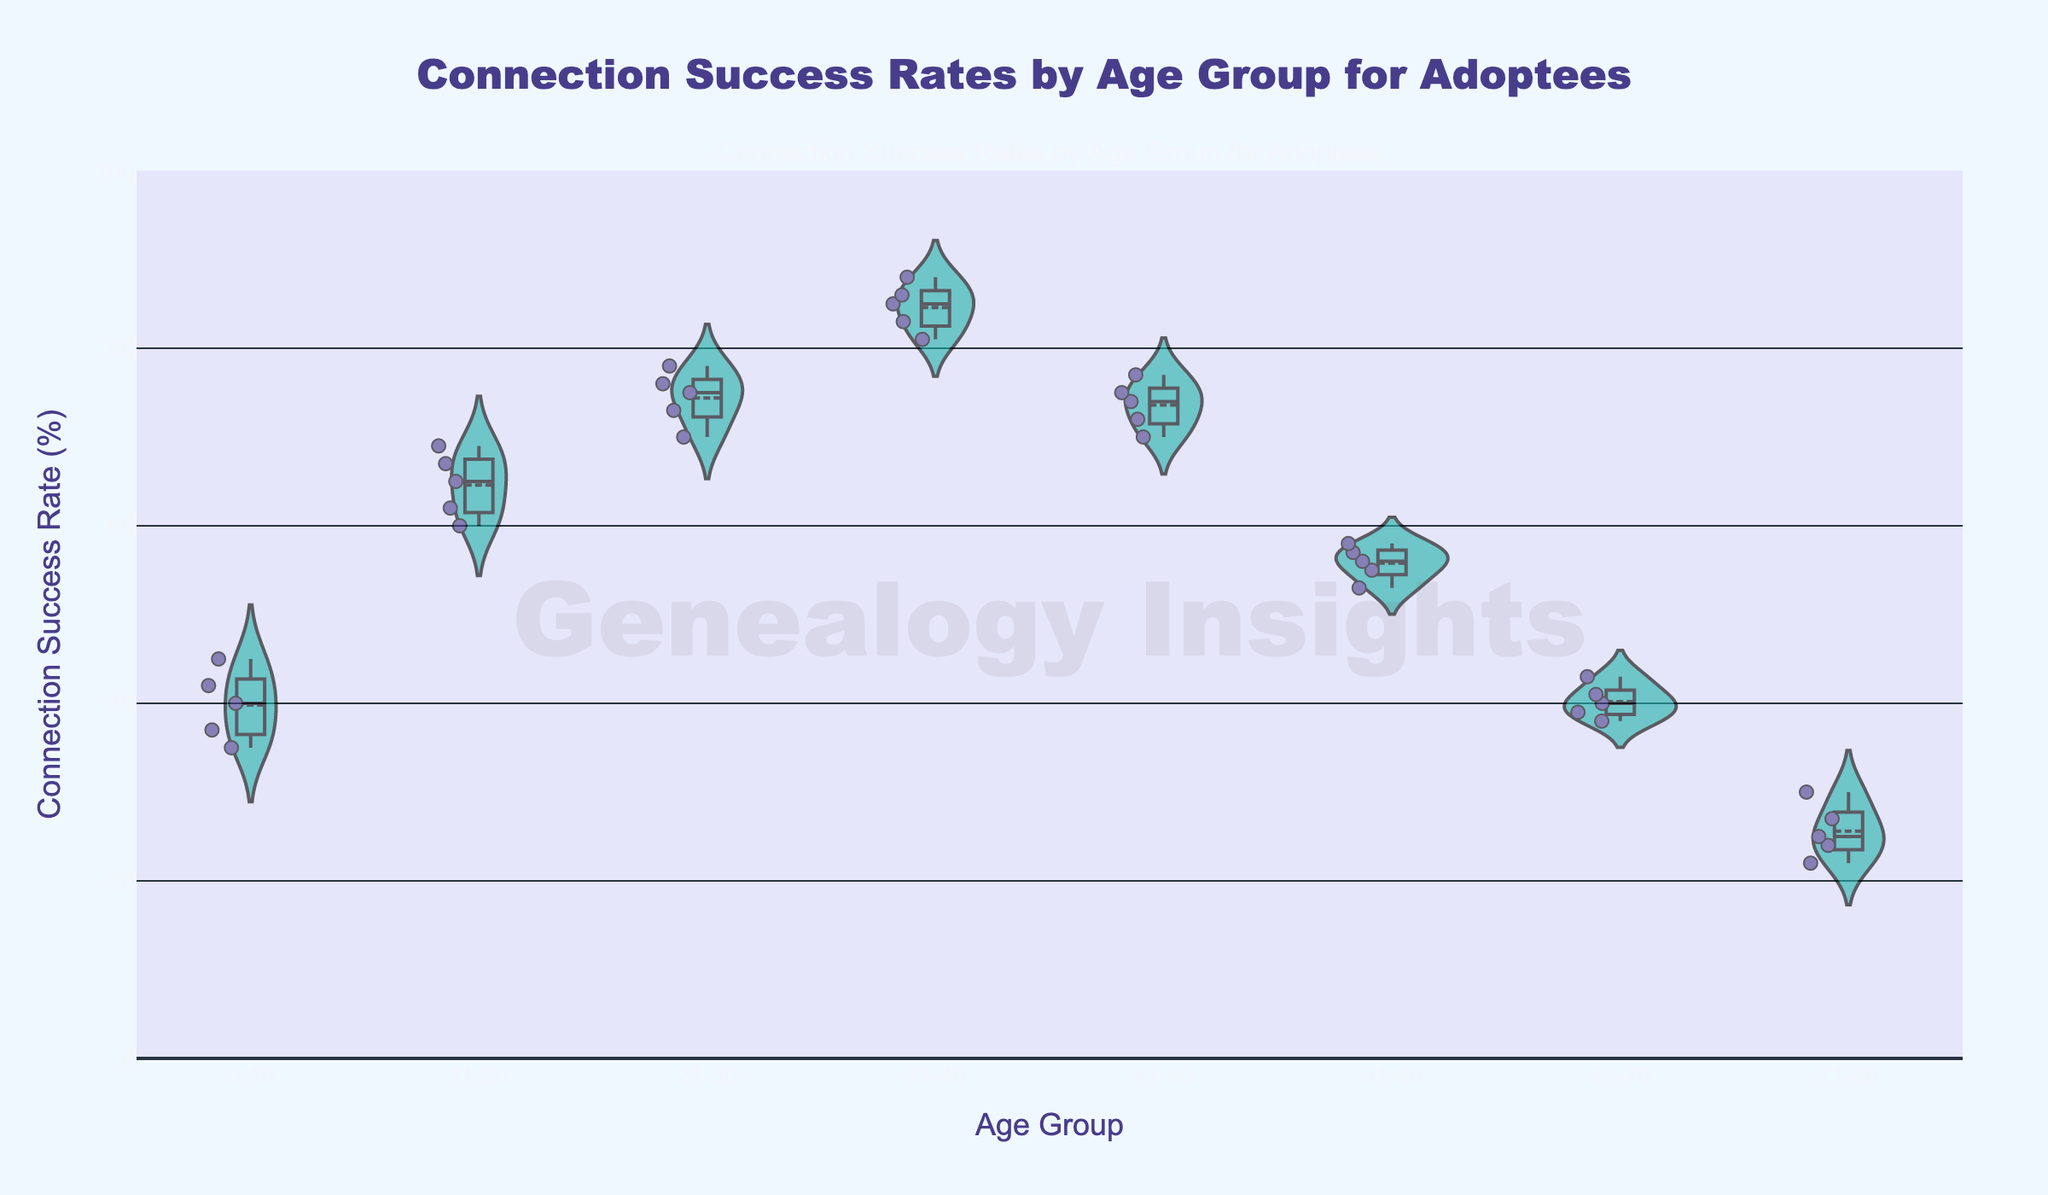How many age groups are represented in the figure? Count the distinct age groups on the x-axis.
Answer: 8 Which age group has the highest median connection success rate? Observe the violin plots' median lines (usually highlighted with meanline) and identify the highest one.
Answer: 31-40 What is the approximate range of connection success rates for the 61-70 age group? Look at the range of data points within the 61-70 violin plot.
Answer: ~38-43 Which two age groups have the most similar median connection success rates? Compare the median lines of each violin plot to find the closest pair.
Answer: 0-10 and 61-70 Are there any visible outliers in the 51-60 age group? Check for individual points that stand out from the rest in the 51-60 violin plot.
Answer: No What is the overall trend in connection success rates as age increases? Analyze the progression of median lines from the youngest to the oldest group.
Answer: Decreasing Which age group shows the highest variability in connection success rates? Identify the violin plot with the widest spread of data points.
Answer: 51-60 How does the median connection success rate for 11-20 compare to that of 71-80? Compare the median lines of the 11-20 and 71-80 violin plots.
Answer: 11-20 is higher What is the mean connection success rate for the 21-30 age group? Calculate the mean from the given data points for the 21-30 group [(75 + 70 + 78 + 73 + 76) / 5].
Answer: 74.4 Is there any age group where the connection success rate drops below 30%? Identify any violin plots with data points below 30%.
Answer: 71-80 